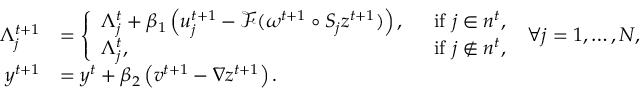Convert formula to latex. <formula><loc_0><loc_0><loc_500><loc_500>\begin{array} { r l } { \Lambda _ { j } ^ { t + 1 } } & { = \left \{ \begin{array} { l l } { \Lambda _ { j } ^ { t } + \beta _ { 1 } \left ( u _ { j } ^ { t + 1 } - \mathcal { F } ( \omega ^ { t + 1 } \circ S _ { j } z ^ { t + 1 } ) \right ) , \, } & { i f j \in n ^ { t } , } \\ { \Lambda _ { j } ^ { t } , \, } & { i f j \not \in n ^ { t } , } \end{array} \, \forall j = 1 , \dots , N , } \\ { y ^ { t + 1 } } & { = y ^ { t } + \beta _ { 2 } \left ( v ^ { t + 1 } - \nabla z ^ { t + 1 } \right ) . } \end{array}</formula> 